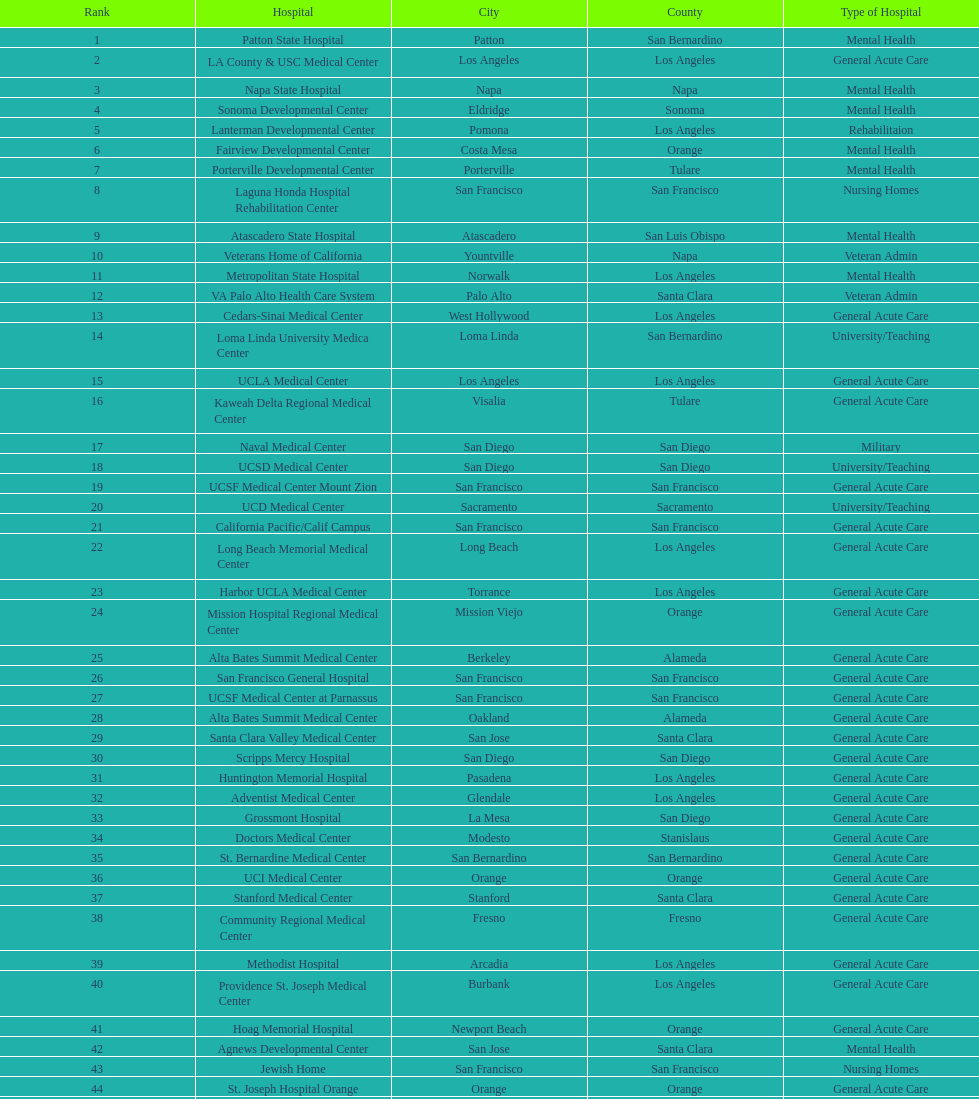How many more general acute care hospitals are there in california than rehabilitation hospitals? 33. 